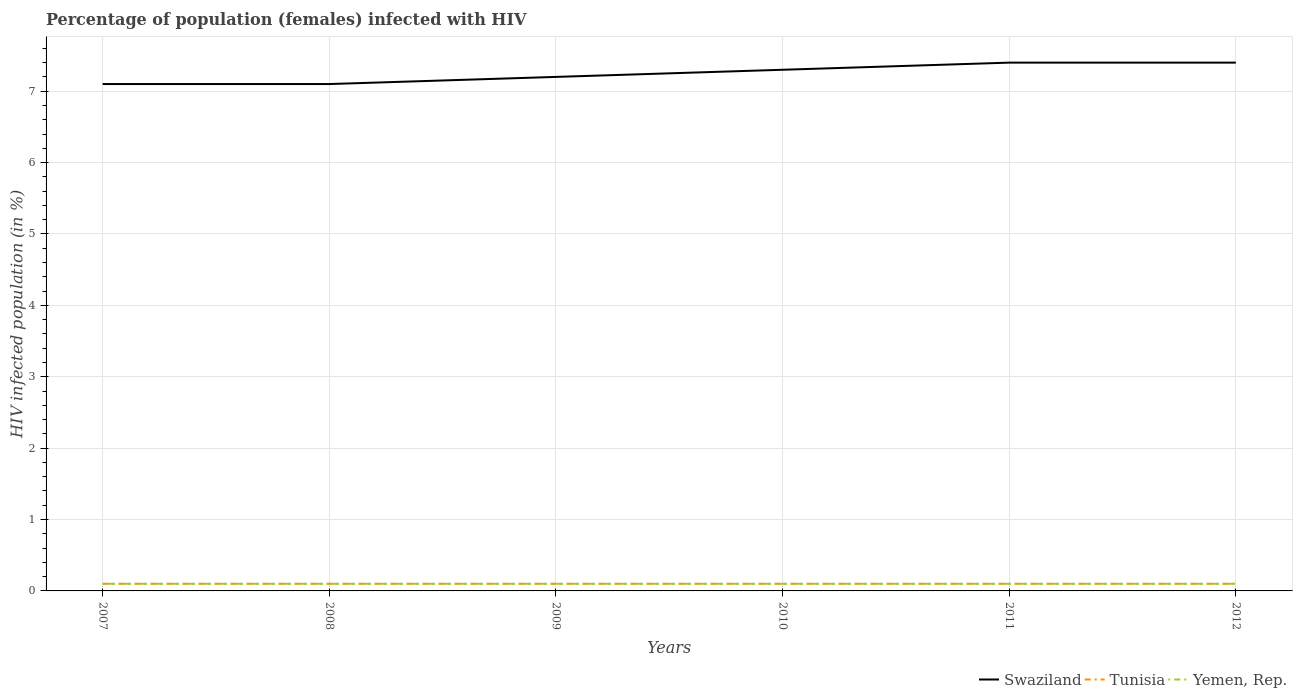Does the line corresponding to Yemen, Rep. intersect with the line corresponding to Tunisia?
Give a very brief answer. Yes. Across all years, what is the maximum percentage of HIV infected female population in Tunisia?
Your answer should be compact. 0.1. Is the percentage of HIV infected female population in Yemen, Rep. strictly greater than the percentage of HIV infected female population in Tunisia over the years?
Make the answer very short. No. How many lines are there?
Offer a terse response. 3. Where does the legend appear in the graph?
Ensure brevity in your answer.  Bottom right. How many legend labels are there?
Offer a terse response. 3. How are the legend labels stacked?
Provide a succinct answer. Horizontal. What is the title of the graph?
Give a very brief answer. Percentage of population (females) infected with HIV. What is the label or title of the Y-axis?
Your answer should be compact. HIV infected population (in %). What is the HIV infected population (in %) in Swaziland in 2007?
Your answer should be very brief. 7.1. What is the HIV infected population (in %) in Yemen, Rep. in 2007?
Provide a succinct answer. 0.1. What is the HIV infected population (in %) of Swaziland in 2008?
Offer a very short reply. 7.1. What is the HIV infected population (in %) in Yemen, Rep. in 2008?
Ensure brevity in your answer.  0.1. What is the HIV infected population (in %) of Tunisia in 2010?
Keep it short and to the point. 0.1. What is the HIV infected population (in %) in Swaziland in 2011?
Make the answer very short. 7.4. What is the HIV infected population (in %) in Yemen, Rep. in 2011?
Offer a terse response. 0.1. What is the HIV infected population (in %) of Tunisia in 2012?
Provide a succinct answer. 0.1. Across all years, what is the maximum HIV infected population (in %) of Yemen, Rep.?
Offer a terse response. 0.1. What is the total HIV infected population (in %) in Swaziland in the graph?
Provide a succinct answer. 43.5. What is the total HIV infected population (in %) in Yemen, Rep. in the graph?
Your answer should be very brief. 0.6. What is the difference between the HIV infected population (in %) in Swaziland in 2007 and that in 2008?
Give a very brief answer. 0. What is the difference between the HIV infected population (in %) in Tunisia in 2007 and that in 2008?
Keep it short and to the point. 0. What is the difference between the HIV infected population (in %) in Yemen, Rep. in 2007 and that in 2009?
Offer a very short reply. 0. What is the difference between the HIV infected population (in %) of Swaziland in 2007 and that in 2010?
Your answer should be very brief. -0.2. What is the difference between the HIV infected population (in %) in Tunisia in 2007 and that in 2011?
Your answer should be compact. 0. What is the difference between the HIV infected population (in %) of Yemen, Rep. in 2007 and that in 2011?
Your response must be concise. 0. What is the difference between the HIV infected population (in %) of Yemen, Rep. in 2008 and that in 2009?
Keep it short and to the point. 0. What is the difference between the HIV infected population (in %) of Swaziland in 2008 and that in 2010?
Give a very brief answer. -0.2. What is the difference between the HIV infected population (in %) in Tunisia in 2008 and that in 2010?
Make the answer very short. 0. What is the difference between the HIV infected population (in %) in Tunisia in 2008 and that in 2011?
Make the answer very short. 0. What is the difference between the HIV infected population (in %) of Swaziland in 2008 and that in 2012?
Make the answer very short. -0.3. What is the difference between the HIV infected population (in %) of Tunisia in 2008 and that in 2012?
Your response must be concise. 0. What is the difference between the HIV infected population (in %) in Tunisia in 2009 and that in 2010?
Give a very brief answer. 0. What is the difference between the HIV infected population (in %) in Yemen, Rep. in 2009 and that in 2010?
Offer a terse response. 0. What is the difference between the HIV infected population (in %) in Yemen, Rep. in 2009 and that in 2011?
Give a very brief answer. 0. What is the difference between the HIV infected population (in %) in Swaziland in 2009 and that in 2012?
Your answer should be compact. -0.2. What is the difference between the HIV infected population (in %) of Yemen, Rep. in 2009 and that in 2012?
Your answer should be very brief. 0. What is the difference between the HIV infected population (in %) of Tunisia in 2010 and that in 2012?
Your response must be concise. 0. What is the difference between the HIV infected population (in %) of Yemen, Rep. in 2010 and that in 2012?
Offer a terse response. 0. What is the difference between the HIV infected population (in %) in Yemen, Rep. in 2011 and that in 2012?
Make the answer very short. 0. What is the difference between the HIV infected population (in %) in Swaziland in 2007 and the HIV infected population (in %) in Tunisia in 2008?
Ensure brevity in your answer.  7. What is the difference between the HIV infected population (in %) of Tunisia in 2007 and the HIV infected population (in %) of Yemen, Rep. in 2008?
Provide a succinct answer. 0. What is the difference between the HIV infected population (in %) of Swaziland in 2007 and the HIV infected population (in %) of Yemen, Rep. in 2009?
Make the answer very short. 7. What is the difference between the HIV infected population (in %) in Tunisia in 2007 and the HIV infected population (in %) in Yemen, Rep. in 2009?
Your answer should be very brief. 0. What is the difference between the HIV infected population (in %) in Swaziland in 2007 and the HIV infected population (in %) in Yemen, Rep. in 2010?
Your answer should be very brief. 7. What is the difference between the HIV infected population (in %) in Tunisia in 2007 and the HIV infected population (in %) in Yemen, Rep. in 2010?
Offer a very short reply. 0. What is the difference between the HIV infected population (in %) in Swaziland in 2007 and the HIV infected population (in %) in Tunisia in 2011?
Offer a terse response. 7. What is the difference between the HIV infected population (in %) in Swaziland in 2008 and the HIV infected population (in %) in Yemen, Rep. in 2009?
Your answer should be very brief. 7. What is the difference between the HIV infected population (in %) of Tunisia in 2008 and the HIV infected population (in %) of Yemen, Rep. in 2009?
Make the answer very short. 0. What is the difference between the HIV infected population (in %) of Swaziland in 2008 and the HIV infected population (in %) of Yemen, Rep. in 2010?
Give a very brief answer. 7. What is the difference between the HIV infected population (in %) in Tunisia in 2008 and the HIV infected population (in %) in Yemen, Rep. in 2010?
Give a very brief answer. 0. What is the difference between the HIV infected population (in %) in Tunisia in 2008 and the HIV infected population (in %) in Yemen, Rep. in 2011?
Ensure brevity in your answer.  0. What is the difference between the HIV infected population (in %) of Swaziland in 2008 and the HIV infected population (in %) of Tunisia in 2012?
Your answer should be very brief. 7. What is the difference between the HIV infected population (in %) in Tunisia in 2008 and the HIV infected population (in %) in Yemen, Rep. in 2012?
Offer a very short reply. 0. What is the difference between the HIV infected population (in %) of Swaziland in 2009 and the HIV infected population (in %) of Tunisia in 2010?
Your answer should be very brief. 7.1. What is the difference between the HIV infected population (in %) in Tunisia in 2009 and the HIV infected population (in %) in Yemen, Rep. in 2010?
Your answer should be compact. 0. What is the difference between the HIV infected population (in %) of Swaziland in 2009 and the HIV infected population (in %) of Tunisia in 2011?
Offer a very short reply. 7.1. What is the difference between the HIV infected population (in %) of Swaziland in 2009 and the HIV infected population (in %) of Tunisia in 2012?
Provide a succinct answer. 7.1. What is the difference between the HIV infected population (in %) of Tunisia in 2010 and the HIV infected population (in %) of Yemen, Rep. in 2011?
Give a very brief answer. 0. What is the difference between the HIV infected population (in %) of Swaziland in 2010 and the HIV infected population (in %) of Yemen, Rep. in 2012?
Make the answer very short. 7.2. What is the difference between the HIV infected population (in %) of Swaziland in 2011 and the HIV infected population (in %) of Tunisia in 2012?
Keep it short and to the point. 7.3. What is the difference between the HIV infected population (in %) of Swaziland in 2011 and the HIV infected population (in %) of Yemen, Rep. in 2012?
Ensure brevity in your answer.  7.3. What is the difference between the HIV infected population (in %) of Tunisia in 2011 and the HIV infected population (in %) of Yemen, Rep. in 2012?
Give a very brief answer. 0. What is the average HIV infected population (in %) in Swaziland per year?
Ensure brevity in your answer.  7.25. What is the average HIV infected population (in %) in Yemen, Rep. per year?
Offer a terse response. 0.1. In the year 2007, what is the difference between the HIV infected population (in %) in Swaziland and HIV infected population (in %) in Yemen, Rep.?
Provide a succinct answer. 7. In the year 2007, what is the difference between the HIV infected population (in %) in Tunisia and HIV infected population (in %) in Yemen, Rep.?
Provide a succinct answer. 0. In the year 2008, what is the difference between the HIV infected population (in %) of Swaziland and HIV infected population (in %) of Tunisia?
Keep it short and to the point. 7. In the year 2008, what is the difference between the HIV infected population (in %) in Swaziland and HIV infected population (in %) in Yemen, Rep.?
Your answer should be very brief. 7. In the year 2009, what is the difference between the HIV infected population (in %) in Swaziland and HIV infected population (in %) in Tunisia?
Give a very brief answer. 7.1. In the year 2009, what is the difference between the HIV infected population (in %) in Swaziland and HIV infected population (in %) in Yemen, Rep.?
Keep it short and to the point. 7.1. In the year 2010, what is the difference between the HIV infected population (in %) of Swaziland and HIV infected population (in %) of Yemen, Rep.?
Ensure brevity in your answer.  7.2. In the year 2011, what is the difference between the HIV infected population (in %) of Swaziland and HIV infected population (in %) of Tunisia?
Your answer should be compact. 7.3. In the year 2011, what is the difference between the HIV infected population (in %) in Swaziland and HIV infected population (in %) in Yemen, Rep.?
Ensure brevity in your answer.  7.3. In the year 2012, what is the difference between the HIV infected population (in %) of Swaziland and HIV infected population (in %) of Yemen, Rep.?
Keep it short and to the point. 7.3. In the year 2012, what is the difference between the HIV infected population (in %) of Tunisia and HIV infected population (in %) of Yemen, Rep.?
Provide a short and direct response. 0. What is the ratio of the HIV infected population (in %) of Swaziland in 2007 to that in 2008?
Ensure brevity in your answer.  1. What is the ratio of the HIV infected population (in %) of Swaziland in 2007 to that in 2009?
Your answer should be compact. 0.99. What is the ratio of the HIV infected population (in %) of Tunisia in 2007 to that in 2009?
Provide a short and direct response. 1. What is the ratio of the HIV infected population (in %) of Swaziland in 2007 to that in 2010?
Your response must be concise. 0.97. What is the ratio of the HIV infected population (in %) of Tunisia in 2007 to that in 2010?
Your answer should be compact. 1. What is the ratio of the HIV infected population (in %) in Swaziland in 2007 to that in 2011?
Offer a terse response. 0.96. What is the ratio of the HIV infected population (in %) of Yemen, Rep. in 2007 to that in 2011?
Provide a short and direct response. 1. What is the ratio of the HIV infected population (in %) in Swaziland in 2007 to that in 2012?
Your answer should be very brief. 0.96. What is the ratio of the HIV infected population (in %) in Tunisia in 2007 to that in 2012?
Your answer should be very brief. 1. What is the ratio of the HIV infected population (in %) in Yemen, Rep. in 2007 to that in 2012?
Give a very brief answer. 1. What is the ratio of the HIV infected population (in %) in Swaziland in 2008 to that in 2009?
Provide a short and direct response. 0.99. What is the ratio of the HIV infected population (in %) of Tunisia in 2008 to that in 2009?
Offer a very short reply. 1. What is the ratio of the HIV infected population (in %) in Swaziland in 2008 to that in 2010?
Your response must be concise. 0.97. What is the ratio of the HIV infected population (in %) in Swaziland in 2008 to that in 2011?
Provide a succinct answer. 0.96. What is the ratio of the HIV infected population (in %) of Tunisia in 2008 to that in 2011?
Offer a very short reply. 1. What is the ratio of the HIV infected population (in %) of Swaziland in 2008 to that in 2012?
Your answer should be very brief. 0.96. What is the ratio of the HIV infected population (in %) in Yemen, Rep. in 2008 to that in 2012?
Your response must be concise. 1. What is the ratio of the HIV infected population (in %) in Swaziland in 2009 to that in 2010?
Your answer should be very brief. 0.99. What is the ratio of the HIV infected population (in %) in Tunisia in 2009 to that in 2010?
Your answer should be very brief. 1. What is the ratio of the HIV infected population (in %) of Yemen, Rep. in 2009 to that in 2010?
Keep it short and to the point. 1. What is the ratio of the HIV infected population (in %) in Yemen, Rep. in 2009 to that in 2011?
Make the answer very short. 1. What is the ratio of the HIV infected population (in %) of Swaziland in 2010 to that in 2011?
Ensure brevity in your answer.  0.99. What is the ratio of the HIV infected population (in %) in Tunisia in 2010 to that in 2011?
Your answer should be very brief. 1. What is the ratio of the HIV infected population (in %) of Yemen, Rep. in 2010 to that in 2011?
Offer a very short reply. 1. What is the ratio of the HIV infected population (in %) in Swaziland in 2010 to that in 2012?
Offer a terse response. 0.99. What is the ratio of the HIV infected population (in %) of Yemen, Rep. in 2010 to that in 2012?
Make the answer very short. 1. What is the ratio of the HIV infected population (in %) of Swaziland in 2011 to that in 2012?
Provide a succinct answer. 1. What is the difference between the highest and the second highest HIV infected population (in %) of Yemen, Rep.?
Keep it short and to the point. 0. What is the difference between the highest and the lowest HIV infected population (in %) in Tunisia?
Make the answer very short. 0. What is the difference between the highest and the lowest HIV infected population (in %) in Yemen, Rep.?
Make the answer very short. 0. 